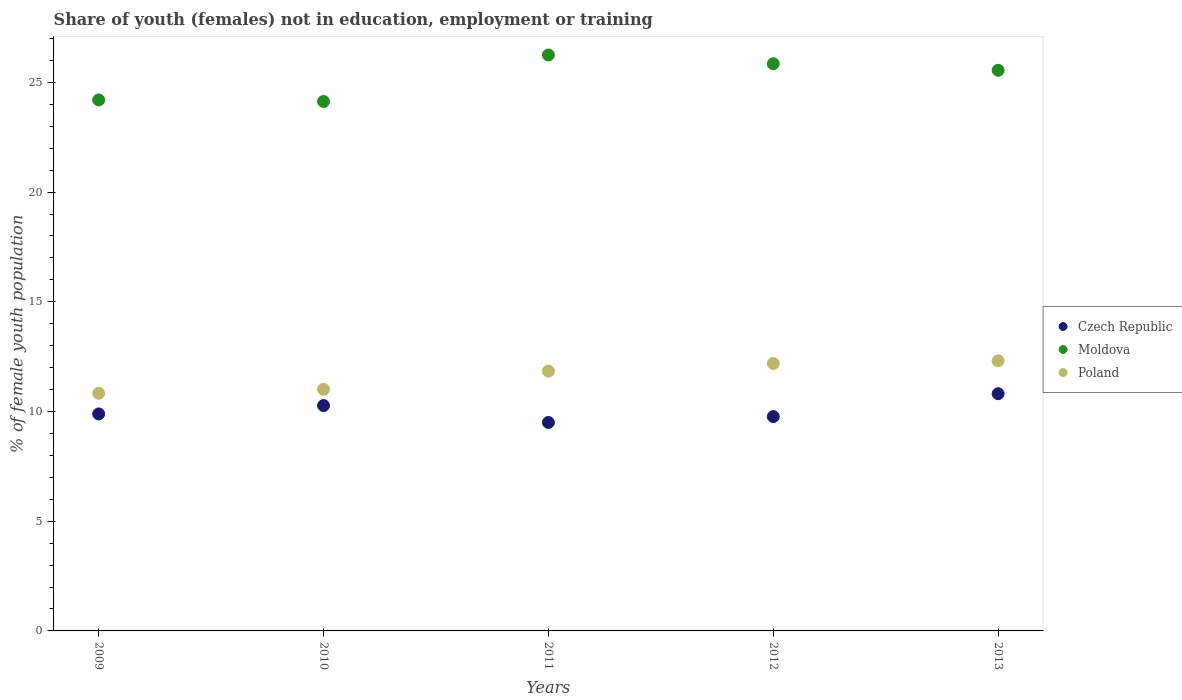How many different coloured dotlines are there?
Offer a terse response. 3. Is the number of dotlines equal to the number of legend labels?
Ensure brevity in your answer.  Yes. What is the percentage of unemployed female population in in Poland in 2011?
Ensure brevity in your answer.  11.84. Across all years, what is the maximum percentage of unemployed female population in in Moldova?
Ensure brevity in your answer.  26.25. What is the total percentage of unemployed female population in in Moldova in the graph?
Your answer should be very brief. 125.98. What is the difference between the percentage of unemployed female population in in Czech Republic in 2011 and that in 2013?
Give a very brief answer. -1.31. What is the difference between the percentage of unemployed female population in in Czech Republic in 2012 and the percentage of unemployed female population in in Moldova in 2009?
Your answer should be very brief. -14.43. What is the average percentage of unemployed female population in in Czech Republic per year?
Make the answer very short. 10.05. In the year 2013, what is the difference between the percentage of unemployed female population in in Moldova and percentage of unemployed female population in in Poland?
Give a very brief answer. 13.24. What is the ratio of the percentage of unemployed female population in in Poland in 2009 to that in 2010?
Your answer should be compact. 0.98. What is the difference between the highest and the second highest percentage of unemployed female population in in Moldova?
Provide a short and direct response. 0.4. What is the difference between the highest and the lowest percentage of unemployed female population in in Czech Republic?
Make the answer very short. 1.31. In how many years, is the percentage of unemployed female population in in Poland greater than the average percentage of unemployed female population in in Poland taken over all years?
Ensure brevity in your answer.  3. Does the percentage of unemployed female population in in Moldova monotonically increase over the years?
Your answer should be very brief. No. Is the percentage of unemployed female population in in Poland strictly greater than the percentage of unemployed female population in in Moldova over the years?
Provide a short and direct response. No. How many dotlines are there?
Keep it short and to the point. 3. Does the graph contain any zero values?
Give a very brief answer. No. How are the legend labels stacked?
Make the answer very short. Vertical. What is the title of the graph?
Provide a succinct answer. Share of youth (females) not in education, employment or training. Does "Burkina Faso" appear as one of the legend labels in the graph?
Give a very brief answer. No. What is the label or title of the X-axis?
Provide a succinct answer. Years. What is the label or title of the Y-axis?
Offer a terse response. % of female youth population. What is the % of female youth population of Czech Republic in 2009?
Provide a short and direct response. 9.89. What is the % of female youth population in Moldova in 2009?
Offer a terse response. 24.2. What is the % of female youth population of Poland in 2009?
Offer a very short reply. 10.83. What is the % of female youth population in Czech Republic in 2010?
Give a very brief answer. 10.27. What is the % of female youth population in Moldova in 2010?
Make the answer very short. 24.13. What is the % of female youth population of Poland in 2010?
Your answer should be very brief. 11.01. What is the % of female youth population of Czech Republic in 2011?
Offer a very short reply. 9.5. What is the % of female youth population of Moldova in 2011?
Your answer should be very brief. 26.25. What is the % of female youth population of Poland in 2011?
Keep it short and to the point. 11.84. What is the % of female youth population of Czech Republic in 2012?
Offer a very short reply. 9.77. What is the % of female youth population in Moldova in 2012?
Give a very brief answer. 25.85. What is the % of female youth population of Poland in 2012?
Offer a terse response. 12.19. What is the % of female youth population of Czech Republic in 2013?
Offer a terse response. 10.81. What is the % of female youth population in Moldova in 2013?
Make the answer very short. 25.55. What is the % of female youth population in Poland in 2013?
Offer a very short reply. 12.31. Across all years, what is the maximum % of female youth population in Czech Republic?
Provide a short and direct response. 10.81. Across all years, what is the maximum % of female youth population of Moldova?
Keep it short and to the point. 26.25. Across all years, what is the maximum % of female youth population in Poland?
Offer a terse response. 12.31. Across all years, what is the minimum % of female youth population in Czech Republic?
Your response must be concise. 9.5. Across all years, what is the minimum % of female youth population in Moldova?
Ensure brevity in your answer.  24.13. Across all years, what is the minimum % of female youth population of Poland?
Provide a short and direct response. 10.83. What is the total % of female youth population of Czech Republic in the graph?
Provide a succinct answer. 50.24. What is the total % of female youth population of Moldova in the graph?
Provide a succinct answer. 125.98. What is the total % of female youth population of Poland in the graph?
Your answer should be very brief. 58.18. What is the difference between the % of female youth population of Czech Republic in 2009 and that in 2010?
Offer a very short reply. -0.38. What is the difference between the % of female youth population of Moldova in 2009 and that in 2010?
Your answer should be compact. 0.07. What is the difference between the % of female youth population in Poland in 2009 and that in 2010?
Provide a short and direct response. -0.18. What is the difference between the % of female youth population of Czech Republic in 2009 and that in 2011?
Offer a very short reply. 0.39. What is the difference between the % of female youth population in Moldova in 2009 and that in 2011?
Keep it short and to the point. -2.05. What is the difference between the % of female youth population in Poland in 2009 and that in 2011?
Offer a very short reply. -1.01. What is the difference between the % of female youth population in Czech Republic in 2009 and that in 2012?
Your answer should be very brief. 0.12. What is the difference between the % of female youth population of Moldova in 2009 and that in 2012?
Offer a very short reply. -1.65. What is the difference between the % of female youth population in Poland in 2009 and that in 2012?
Give a very brief answer. -1.36. What is the difference between the % of female youth population in Czech Republic in 2009 and that in 2013?
Make the answer very short. -0.92. What is the difference between the % of female youth population of Moldova in 2009 and that in 2013?
Provide a short and direct response. -1.35. What is the difference between the % of female youth population of Poland in 2009 and that in 2013?
Provide a succinct answer. -1.48. What is the difference between the % of female youth population of Czech Republic in 2010 and that in 2011?
Provide a short and direct response. 0.77. What is the difference between the % of female youth population of Moldova in 2010 and that in 2011?
Offer a terse response. -2.12. What is the difference between the % of female youth population in Poland in 2010 and that in 2011?
Your answer should be very brief. -0.83. What is the difference between the % of female youth population of Czech Republic in 2010 and that in 2012?
Offer a terse response. 0.5. What is the difference between the % of female youth population in Moldova in 2010 and that in 2012?
Provide a short and direct response. -1.72. What is the difference between the % of female youth population in Poland in 2010 and that in 2012?
Give a very brief answer. -1.18. What is the difference between the % of female youth population of Czech Republic in 2010 and that in 2013?
Offer a terse response. -0.54. What is the difference between the % of female youth population in Moldova in 2010 and that in 2013?
Keep it short and to the point. -1.42. What is the difference between the % of female youth population in Poland in 2010 and that in 2013?
Provide a succinct answer. -1.3. What is the difference between the % of female youth population of Czech Republic in 2011 and that in 2012?
Keep it short and to the point. -0.27. What is the difference between the % of female youth population in Poland in 2011 and that in 2012?
Your answer should be very brief. -0.35. What is the difference between the % of female youth population in Czech Republic in 2011 and that in 2013?
Your answer should be compact. -1.31. What is the difference between the % of female youth population of Poland in 2011 and that in 2013?
Give a very brief answer. -0.47. What is the difference between the % of female youth population in Czech Republic in 2012 and that in 2013?
Provide a short and direct response. -1.04. What is the difference between the % of female youth population in Moldova in 2012 and that in 2013?
Ensure brevity in your answer.  0.3. What is the difference between the % of female youth population in Poland in 2012 and that in 2013?
Your answer should be very brief. -0.12. What is the difference between the % of female youth population in Czech Republic in 2009 and the % of female youth population in Moldova in 2010?
Provide a short and direct response. -14.24. What is the difference between the % of female youth population in Czech Republic in 2009 and the % of female youth population in Poland in 2010?
Offer a very short reply. -1.12. What is the difference between the % of female youth population in Moldova in 2009 and the % of female youth population in Poland in 2010?
Provide a succinct answer. 13.19. What is the difference between the % of female youth population of Czech Republic in 2009 and the % of female youth population of Moldova in 2011?
Offer a terse response. -16.36. What is the difference between the % of female youth population of Czech Republic in 2009 and the % of female youth population of Poland in 2011?
Your answer should be compact. -1.95. What is the difference between the % of female youth population of Moldova in 2009 and the % of female youth population of Poland in 2011?
Give a very brief answer. 12.36. What is the difference between the % of female youth population of Czech Republic in 2009 and the % of female youth population of Moldova in 2012?
Ensure brevity in your answer.  -15.96. What is the difference between the % of female youth population in Czech Republic in 2009 and the % of female youth population in Poland in 2012?
Your response must be concise. -2.3. What is the difference between the % of female youth population of Moldova in 2009 and the % of female youth population of Poland in 2012?
Provide a succinct answer. 12.01. What is the difference between the % of female youth population of Czech Republic in 2009 and the % of female youth population of Moldova in 2013?
Offer a terse response. -15.66. What is the difference between the % of female youth population in Czech Republic in 2009 and the % of female youth population in Poland in 2013?
Make the answer very short. -2.42. What is the difference between the % of female youth population of Moldova in 2009 and the % of female youth population of Poland in 2013?
Make the answer very short. 11.89. What is the difference between the % of female youth population in Czech Republic in 2010 and the % of female youth population in Moldova in 2011?
Offer a very short reply. -15.98. What is the difference between the % of female youth population in Czech Republic in 2010 and the % of female youth population in Poland in 2011?
Give a very brief answer. -1.57. What is the difference between the % of female youth population of Moldova in 2010 and the % of female youth population of Poland in 2011?
Keep it short and to the point. 12.29. What is the difference between the % of female youth population of Czech Republic in 2010 and the % of female youth population of Moldova in 2012?
Your answer should be very brief. -15.58. What is the difference between the % of female youth population of Czech Republic in 2010 and the % of female youth population of Poland in 2012?
Give a very brief answer. -1.92. What is the difference between the % of female youth population of Moldova in 2010 and the % of female youth population of Poland in 2012?
Offer a terse response. 11.94. What is the difference between the % of female youth population in Czech Republic in 2010 and the % of female youth population in Moldova in 2013?
Your answer should be very brief. -15.28. What is the difference between the % of female youth population of Czech Republic in 2010 and the % of female youth population of Poland in 2013?
Your response must be concise. -2.04. What is the difference between the % of female youth population in Moldova in 2010 and the % of female youth population in Poland in 2013?
Provide a short and direct response. 11.82. What is the difference between the % of female youth population of Czech Republic in 2011 and the % of female youth population of Moldova in 2012?
Offer a terse response. -16.35. What is the difference between the % of female youth population in Czech Republic in 2011 and the % of female youth population in Poland in 2012?
Keep it short and to the point. -2.69. What is the difference between the % of female youth population of Moldova in 2011 and the % of female youth population of Poland in 2012?
Offer a terse response. 14.06. What is the difference between the % of female youth population in Czech Republic in 2011 and the % of female youth population in Moldova in 2013?
Keep it short and to the point. -16.05. What is the difference between the % of female youth population in Czech Republic in 2011 and the % of female youth population in Poland in 2013?
Offer a very short reply. -2.81. What is the difference between the % of female youth population in Moldova in 2011 and the % of female youth population in Poland in 2013?
Provide a short and direct response. 13.94. What is the difference between the % of female youth population of Czech Republic in 2012 and the % of female youth population of Moldova in 2013?
Make the answer very short. -15.78. What is the difference between the % of female youth population in Czech Republic in 2012 and the % of female youth population in Poland in 2013?
Keep it short and to the point. -2.54. What is the difference between the % of female youth population of Moldova in 2012 and the % of female youth population of Poland in 2013?
Offer a very short reply. 13.54. What is the average % of female youth population in Czech Republic per year?
Make the answer very short. 10.05. What is the average % of female youth population in Moldova per year?
Offer a very short reply. 25.2. What is the average % of female youth population of Poland per year?
Provide a short and direct response. 11.64. In the year 2009, what is the difference between the % of female youth population of Czech Republic and % of female youth population of Moldova?
Offer a terse response. -14.31. In the year 2009, what is the difference between the % of female youth population of Czech Republic and % of female youth population of Poland?
Your answer should be compact. -0.94. In the year 2009, what is the difference between the % of female youth population of Moldova and % of female youth population of Poland?
Make the answer very short. 13.37. In the year 2010, what is the difference between the % of female youth population in Czech Republic and % of female youth population in Moldova?
Keep it short and to the point. -13.86. In the year 2010, what is the difference between the % of female youth population of Czech Republic and % of female youth population of Poland?
Your answer should be very brief. -0.74. In the year 2010, what is the difference between the % of female youth population in Moldova and % of female youth population in Poland?
Your answer should be very brief. 13.12. In the year 2011, what is the difference between the % of female youth population in Czech Republic and % of female youth population in Moldova?
Ensure brevity in your answer.  -16.75. In the year 2011, what is the difference between the % of female youth population in Czech Republic and % of female youth population in Poland?
Keep it short and to the point. -2.34. In the year 2011, what is the difference between the % of female youth population of Moldova and % of female youth population of Poland?
Keep it short and to the point. 14.41. In the year 2012, what is the difference between the % of female youth population of Czech Republic and % of female youth population of Moldova?
Give a very brief answer. -16.08. In the year 2012, what is the difference between the % of female youth population in Czech Republic and % of female youth population in Poland?
Your answer should be very brief. -2.42. In the year 2012, what is the difference between the % of female youth population of Moldova and % of female youth population of Poland?
Make the answer very short. 13.66. In the year 2013, what is the difference between the % of female youth population of Czech Republic and % of female youth population of Moldova?
Provide a succinct answer. -14.74. In the year 2013, what is the difference between the % of female youth population in Moldova and % of female youth population in Poland?
Ensure brevity in your answer.  13.24. What is the ratio of the % of female youth population of Czech Republic in 2009 to that in 2010?
Offer a terse response. 0.96. What is the ratio of the % of female youth population of Moldova in 2009 to that in 2010?
Make the answer very short. 1. What is the ratio of the % of female youth population in Poland in 2009 to that in 2010?
Provide a short and direct response. 0.98. What is the ratio of the % of female youth population in Czech Republic in 2009 to that in 2011?
Provide a succinct answer. 1.04. What is the ratio of the % of female youth population of Moldova in 2009 to that in 2011?
Provide a short and direct response. 0.92. What is the ratio of the % of female youth population of Poland in 2009 to that in 2011?
Your answer should be compact. 0.91. What is the ratio of the % of female youth population in Czech Republic in 2009 to that in 2012?
Make the answer very short. 1.01. What is the ratio of the % of female youth population in Moldova in 2009 to that in 2012?
Provide a succinct answer. 0.94. What is the ratio of the % of female youth population of Poland in 2009 to that in 2012?
Your answer should be compact. 0.89. What is the ratio of the % of female youth population in Czech Republic in 2009 to that in 2013?
Provide a succinct answer. 0.91. What is the ratio of the % of female youth population of Moldova in 2009 to that in 2013?
Give a very brief answer. 0.95. What is the ratio of the % of female youth population of Poland in 2009 to that in 2013?
Your answer should be compact. 0.88. What is the ratio of the % of female youth population in Czech Republic in 2010 to that in 2011?
Provide a succinct answer. 1.08. What is the ratio of the % of female youth population in Moldova in 2010 to that in 2011?
Ensure brevity in your answer.  0.92. What is the ratio of the % of female youth population in Poland in 2010 to that in 2011?
Make the answer very short. 0.93. What is the ratio of the % of female youth population of Czech Republic in 2010 to that in 2012?
Your answer should be compact. 1.05. What is the ratio of the % of female youth population of Moldova in 2010 to that in 2012?
Provide a short and direct response. 0.93. What is the ratio of the % of female youth population in Poland in 2010 to that in 2012?
Provide a short and direct response. 0.9. What is the ratio of the % of female youth population in Czech Republic in 2010 to that in 2013?
Your response must be concise. 0.95. What is the ratio of the % of female youth population in Poland in 2010 to that in 2013?
Offer a very short reply. 0.89. What is the ratio of the % of female youth population of Czech Republic in 2011 to that in 2012?
Provide a short and direct response. 0.97. What is the ratio of the % of female youth population of Moldova in 2011 to that in 2012?
Offer a terse response. 1.02. What is the ratio of the % of female youth population of Poland in 2011 to that in 2012?
Offer a very short reply. 0.97. What is the ratio of the % of female youth population of Czech Republic in 2011 to that in 2013?
Your answer should be compact. 0.88. What is the ratio of the % of female youth population in Moldova in 2011 to that in 2013?
Make the answer very short. 1.03. What is the ratio of the % of female youth population of Poland in 2011 to that in 2013?
Make the answer very short. 0.96. What is the ratio of the % of female youth population of Czech Republic in 2012 to that in 2013?
Offer a very short reply. 0.9. What is the ratio of the % of female youth population of Moldova in 2012 to that in 2013?
Your answer should be compact. 1.01. What is the ratio of the % of female youth population in Poland in 2012 to that in 2013?
Your answer should be very brief. 0.99. What is the difference between the highest and the second highest % of female youth population of Czech Republic?
Your answer should be very brief. 0.54. What is the difference between the highest and the second highest % of female youth population in Poland?
Your response must be concise. 0.12. What is the difference between the highest and the lowest % of female youth population of Czech Republic?
Your answer should be very brief. 1.31. What is the difference between the highest and the lowest % of female youth population of Moldova?
Offer a very short reply. 2.12. What is the difference between the highest and the lowest % of female youth population of Poland?
Your response must be concise. 1.48. 